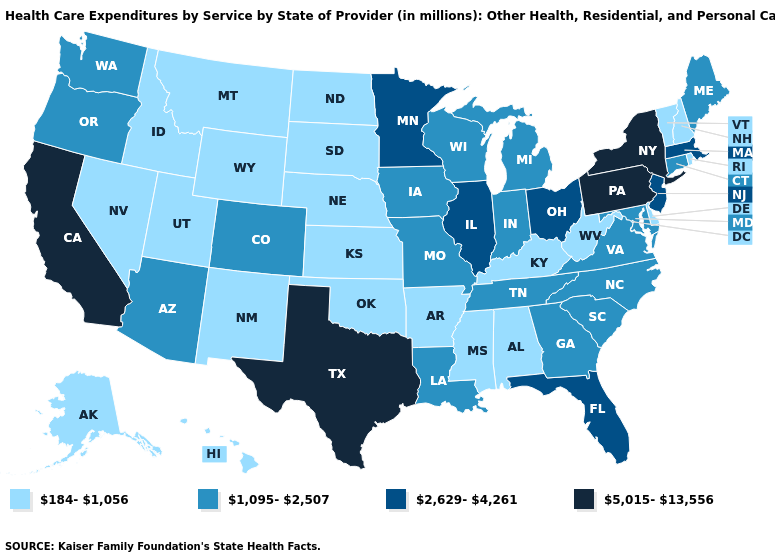Which states have the highest value in the USA?
Give a very brief answer. California, New York, Pennsylvania, Texas. Among the states that border Minnesota , which have the highest value?
Keep it brief. Iowa, Wisconsin. Name the states that have a value in the range 2,629-4,261?
Short answer required. Florida, Illinois, Massachusetts, Minnesota, New Jersey, Ohio. Name the states that have a value in the range 5,015-13,556?
Answer briefly. California, New York, Pennsylvania, Texas. Does Connecticut have the lowest value in the Northeast?
Keep it brief. No. What is the value of Oregon?
Give a very brief answer. 1,095-2,507. Does Kentucky have the lowest value in the South?
Concise answer only. Yes. Which states have the lowest value in the MidWest?
Be succinct. Kansas, Nebraska, North Dakota, South Dakota. Among the states that border Kansas , which have the lowest value?
Be succinct. Nebraska, Oklahoma. Which states have the highest value in the USA?
Quick response, please. California, New York, Pennsylvania, Texas. Among the states that border Iowa , which have the lowest value?
Be succinct. Nebraska, South Dakota. Which states have the highest value in the USA?
Write a very short answer. California, New York, Pennsylvania, Texas. Which states have the lowest value in the USA?
Concise answer only. Alabama, Alaska, Arkansas, Delaware, Hawaii, Idaho, Kansas, Kentucky, Mississippi, Montana, Nebraska, Nevada, New Hampshire, New Mexico, North Dakota, Oklahoma, Rhode Island, South Dakota, Utah, Vermont, West Virginia, Wyoming. Name the states that have a value in the range 2,629-4,261?
Be succinct. Florida, Illinois, Massachusetts, Minnesota, New Jersey, Ohio. What is the highest value in the USA?
Give a very brief answer. 5,015-13,556. 